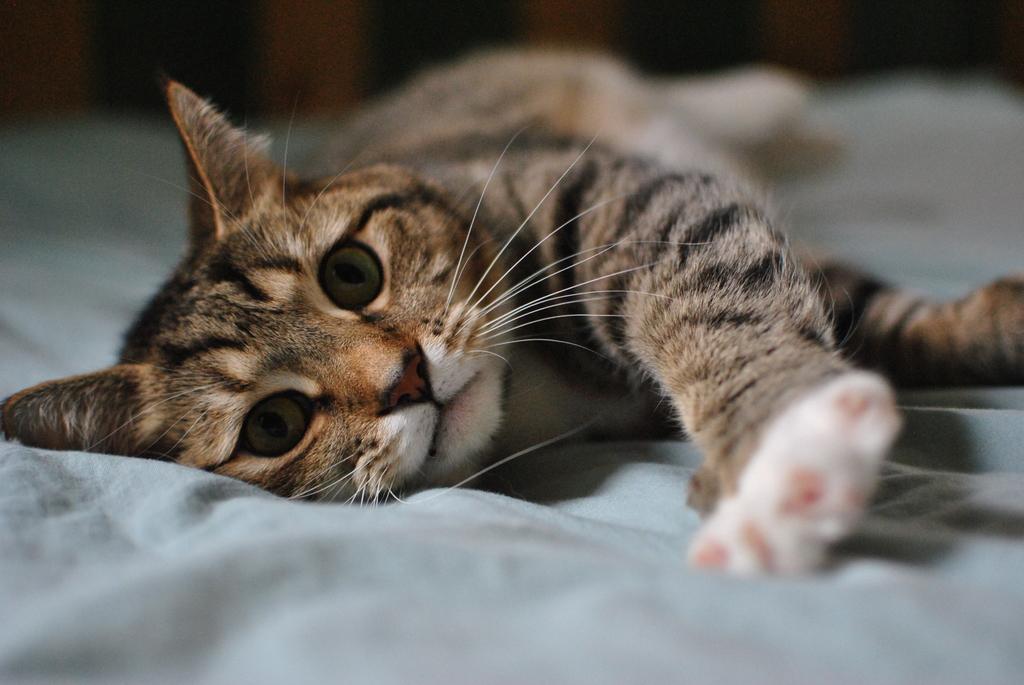In one or two sentences, can you explain what this image depicts? In this picture there is a cat lie down on a cloth under it. 